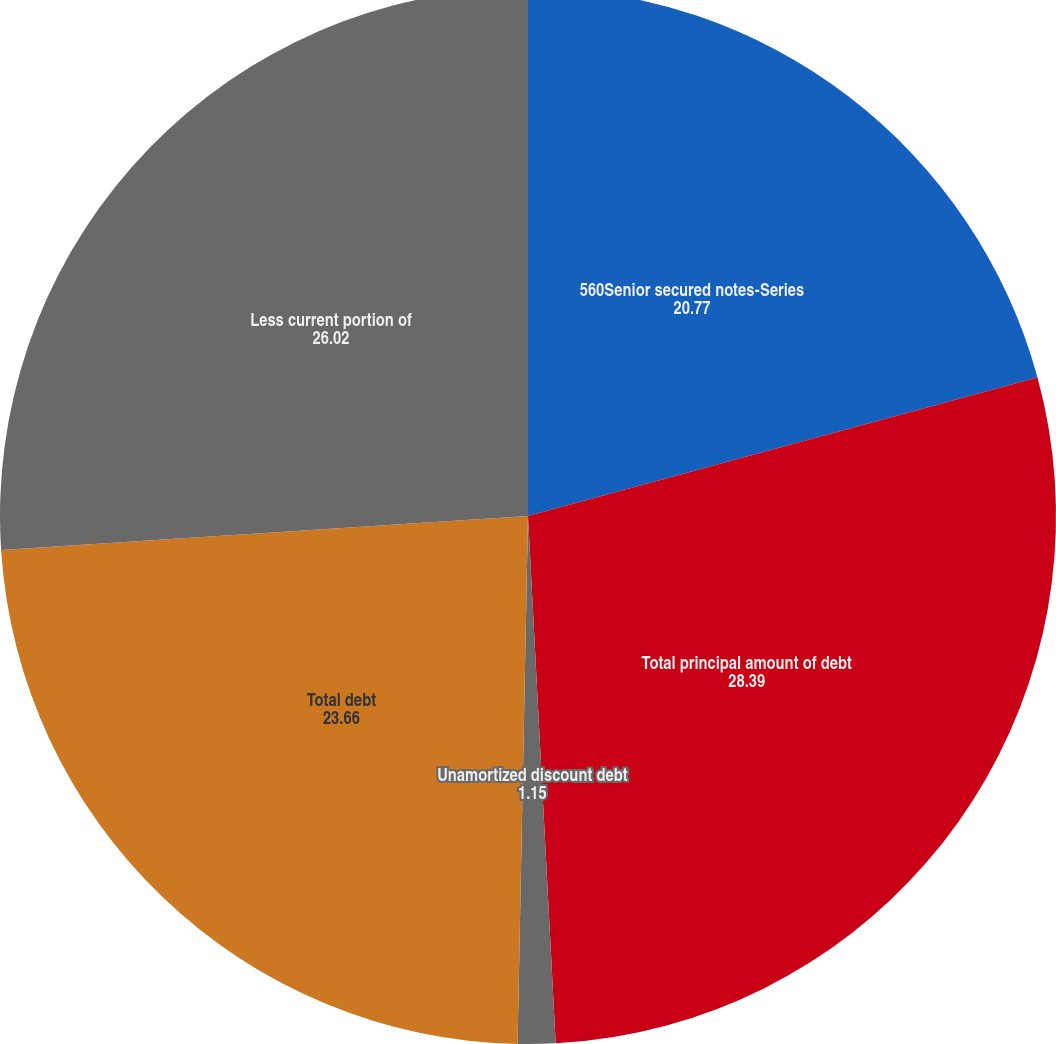Convert chart to OTSL. <chart><loc_0><loc_0><loc_500><loc_500><pie_chart><fcel>560Senior secured notes-Series<fcel>Total principal amount of debt<fcel>Unamortized discount debt<fcel>Total debt<fcel>Less current portion of<nl><fcel>20.77%<fcel>28.39%<fcel>1.15%<fcel>23.66%<fcel>26.02%<nl></chart> 